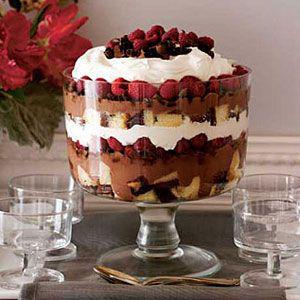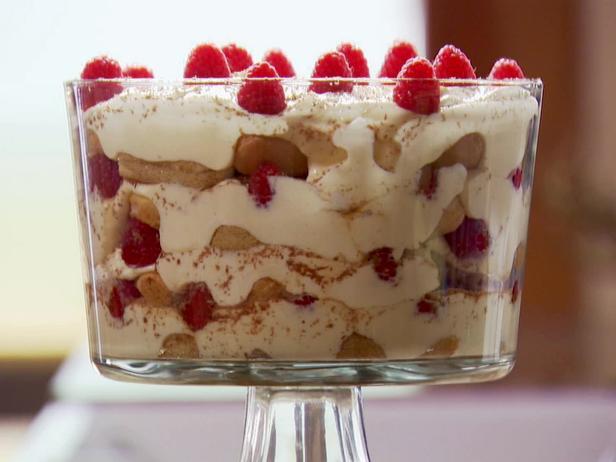The first image is the image on the left, the second image is the image on the right. Examine the images to the left and right. Is the description "An image shows one large dessert in a footed glass, garnished with raspberries on top and not any form of chocolate." accurate? Answer yes or no. Yes. 